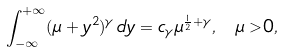<formula> <loc_0><loc_0><loc_500><loc_500>\int _ { - \infty } ^ { + \infty } ( \mu + y ^ { 2 } ) ^ { \gamma } \, d y = c _ { \gamma } \mu ^ { \frac { 1 } { 2 } + \gamma } , \ \mu > 0 ,</formula> 